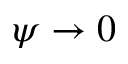<formula> <loc_0><loc_0><loc_500><loc_500>\psi \to 0</formula> 